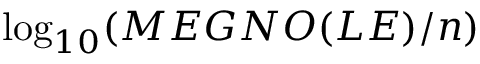Convert formula to latex. <formula><loc_0><loc_0><loc_500><loc_500>\log _ { 1 0 } ( M E G N O ( L E ) / n )</formula> 